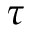<formula> <loc_0><loc_0><loc_500><loc_500>\tau</formula> 